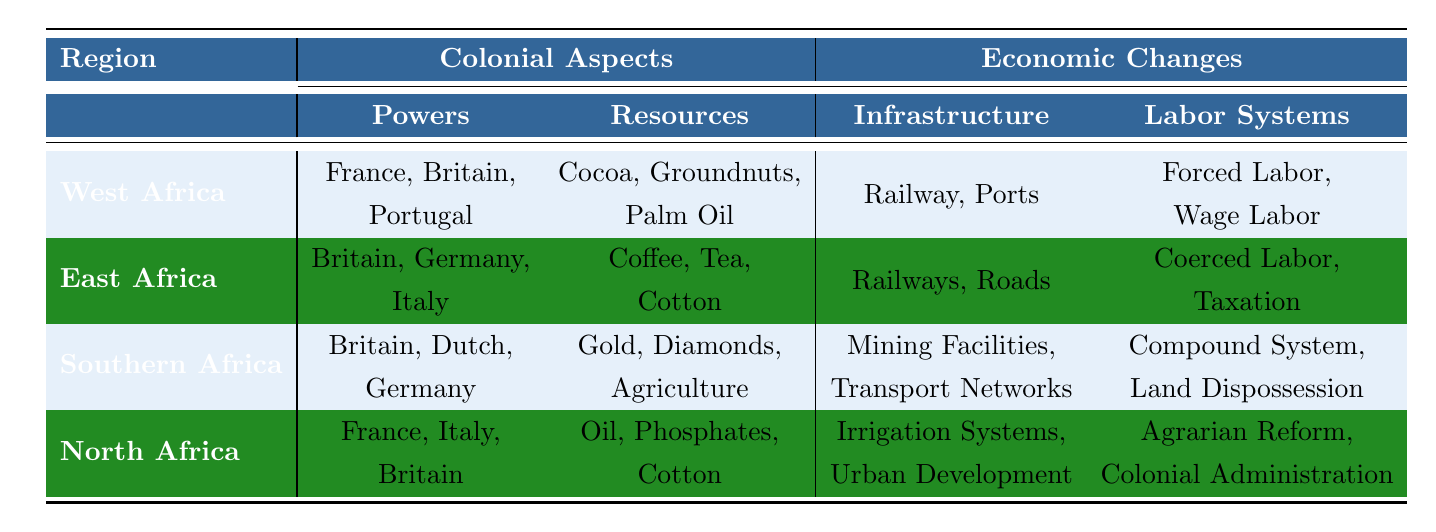What are the main colonial powers in West Africa? The table lists the colonial powers for West Africa as France, Britain, and Portugal.
Answer: France, Britain, Portugal Which resources were key in East Africa? According to the table, the key resources in East Africa include Coffee, Tea, and Cotton.
Answer: Coffee, Tea, Cotton True or False: Gold was a key resource in North Africa. The table shows that the key resources in North Africa are Oil, Phosphates, and Cotton, not Gold.
Answer: False What types of labor systems were used in Southern Africa? The table indicates that the labor systems in Southern Africa included the Compound System and Land Dispossession.
Answer: Compound System, Land Dispossession Which region had the colonial powers of Britain, Germany, and Italy? The table indicates that East Africa was under the colonial powers of Britain, Germany, and Italy.
Answer: East Africa How many types of infrastructure changes are listed for West Africa? The infrastructure changes listed for West Africa include Railway and Ports, which totals to two types.
Answer: 2 What is the difference in key resources between Southern Africa and East Africa? Southern Africa's key resources are Gold, Diamonds, and Agriculture, while East Africa's key resources are Coffee, Tea, and Cotton. The difference is that Southern Africa includes minerals (Gold, Diamonds) while East Africa focuses on agricultural products (Coffee, Tea, Cotton).
Answer: Southern Africa has minerals; East Africa has agricultural products Which labor systems in North Africa indicate a transformation of local economies? The labor systems that indicate a transformation in North Africa are Agrarian Reform, which transformed land ownership patterns, and Colonial Administration, which imposed new tax systems.
Answer: Agrarian Reform, Colonial Administration Explain the primary economic changes in relation to infrastructure across the regions in the table. The table describes varying infrastructure impacts: West Africa improved transport for exports via Railways and Ports; East Africa opened up the interior for resource extraction with Railways and Roads; Southern Africa's Mining Facilities and Transport Networks led to industrialization; while North Africa’s Irrigation Systems modernized agriculture and Urban Development catered to colonial needs.
Answer: Improved transport in West Africa, resource extraction in East Africa, industrialization in Southern Africa, modernized agriculture in North Africa Which region shows a higher emphasis on agricultural resources, East Africa or Southern Africa? East Africa's key resources are Coffee, Tea, and Cotton with an agricultural focus, while Southern Africa includes Gold and Diamonds, which are not agricultural. Therefore, East Africa emphasizes agriculture more than Southern Africa.
Answer: East Africa What types of economic changes were seen in terms of labor systems in West Africa? West Africa saw Forced Labor, which exploited local populations, and Wage Labor that introduced cash economies but limited benefits to locals as its economic changes regarding labor systems.
Answer: Forced Labor, Wage Labor 